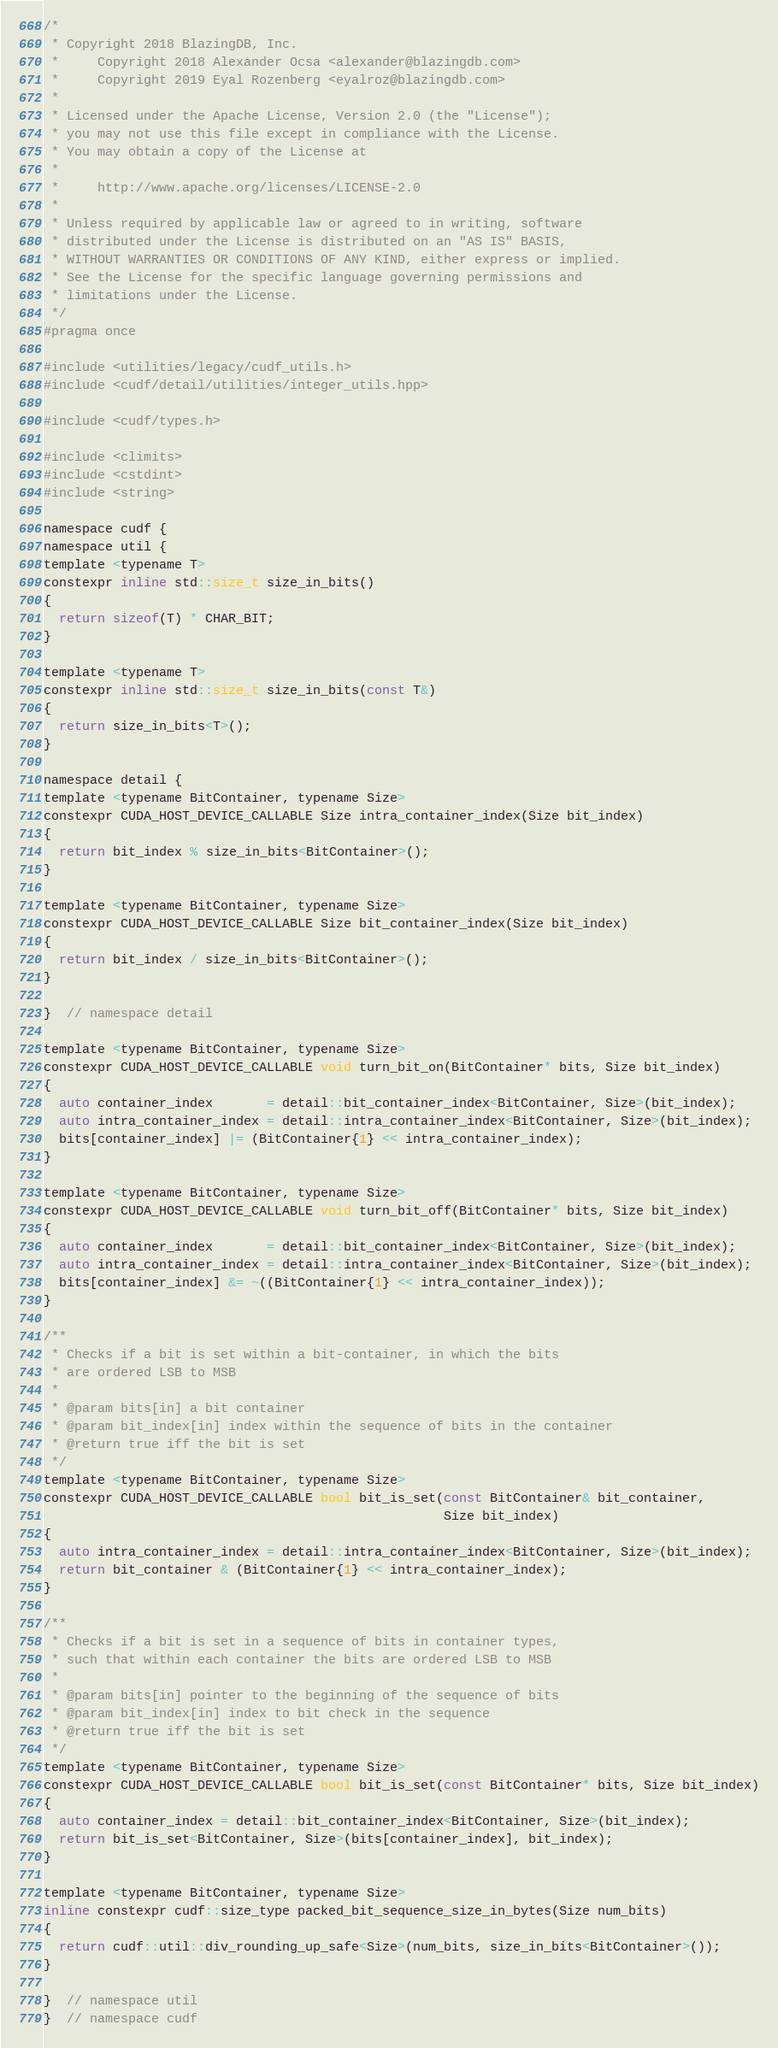Convert code to text. <code><loc_0><loc_0><loc_500><loc_500><_Cuda_>
/*
 * Copyright 2018 BlazingDB, Inc.
 *     Copyright 2018 Alexander Ocsa <alexander@blazingdb.com>
 *     Copyright 2019 Eyal Rozenberg <eyalroz@blazingdb.com>
 *
 * Licensed under the Apache License, Version 2.0 (the "License");
 * you may not use this file except in compliance with the License.
 * You may obtain a copy of the License at
 *
 *     http://www.apache.org/licenses/LICENSE-2.0
 *
 * Unless required by applicable law or agreed to in writing, software
 * distributed under the License is distributed on an "AS IS" BASIS,
 * WITHOUT WARRANTIES OR CONDITIONS OF ANY KIND, either express or implied.
 * See the License for the specific language governing permissions and
 * limitations under the License.
 */
#pragma once

#include <utilities/legacy/cudf_utils.h>
#include <cudf/detail/utilities/integer_utils.hpp>

#include <cudf/types.h>

#include <climits>
#include <cstdint>
#include <string>

namespace cudf {
namespace util {
template <typename T>
constexpr inline std::size_t size_in_bits()
{
  return sizeof(T) * CHAR_BIT;
}

template <typename T>
constexpr inline std::size_t size_in_bits(const T&)
{
  return size_in_bits<T>();
}

namespace detail {
template <typename BitContainer, typename Size>
constexpr CUDA_HOST_DEVICE_CALLABLE Size intra_container_index(Size bit_index)
{
  return bit_index % size_in_bits<BitContainer>();
}

template <typename BitContainer, typename Size>
constexpr CUDA_HOST_DEVICE_CALLABLE Size bit_container_index(Size bit_index)
{
  return bit_index / size_in_bits<BitContainer>();
}

}  // namespace detail

template <typename BitContainer, typename Size>
constexpr CUDA_HOST_DEVICE_CALLABLE void turn_bit_on(BitContainer* bits, Size bit_index)
{
  auto container_index       = detail::bit_container_index<BitContainer, Size>(bit_index);
  auto intra_container_index = detail::intra_container_index<BitContainer, Size>(bit_index);
  bits[container_index] |= (BitContainer{1} << intra_container_index);
}

template <typename BitContainer, typename Size>
constexpr CUDA_HOST_DEVICE_CALLABLE void turn_bit_off(BitContainer* bits, Size bit_index)
{
  auto container_index       = detail::bit_container_index<BitContainer, Size>(bit_index);
  auto intra_container_index = detail::intra_container_index<BitContainer, Size>(bit_index);
  bits[container_index] &= ~((BitContainer{1} << intra_container_index));
}

/**
 * Checks if a bit is set within a bit-container, in which the bits
 * are ordered LSB to MSB
 *
 * @param bits[in] a bit container
 * @param bit_index[in] index within the sequence of bits in the container
 * @return true iff the bit is set
 */
template <typename BitContainer, typename Size>
constexpr CUDA_HOST_DEVICE_CALLABLE bool bit_is_set(const BitContainer& bit_container,
                                                    Size bit_index)
{
  auto intra_container_index = detail::intra_container_index<BitContainer, Size>(bit_index);
  return bit_container & (BitContainer{1} << intra_container_index);
}

/**
 * Checks if a bit is set in a sequence of bits in container types,
 * such that within each container the bits are ordered LSB to MSB
 *
 * @param bits[in] pointer to the beginning of the sequence of bits
 * @param bit_index[in] index to bit check in the sequence
 * @return true iff the bit is set
 */
template <typename BitContainer, typename Size>
constexpr CUDA_HOST_DEVICE_CALLABLE bool bit_is_set(const BitContainer* bits, Size bit_index)
{
  auto container_index = detail::bit_container_index<BitContainer, Size>(bit_index);
  return bit_is_set<BitContainer, Size>(bits[container_index], bit_index);
}

template <typename BitContainer, typename Size>
inline constexpr cudf::size_type packed_bit_sequence_size_in_bytes(Size num_bits)
{
  return cudf::util::div_rounding_up_safe<Size>(num_bits, size_in_bits<BitContainer>());
}

}  // namespace util
}  // namespace cudf
</code> 